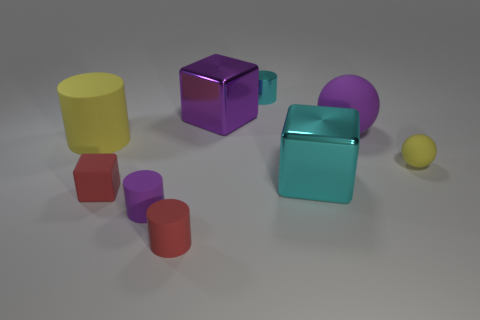How many other objects are there of the same material as the small purple cylinder?
Your answer should be very brief. 5. Do the big object that is on the right side of the large cyan block and the purple thing that is in front of the small ball have the same material?
Provide a succinct answer. Yes. The tiny thing that is the same material as the cyan cube is what shape?
Offer a terse response. Cylinder. Are there any other things that have the same color as the small metal cylinder?
Keep it short and to the point. Yes. How many purple shiny balls are there?
Give a very brief answer. 0. What shape is the metallic object that is both on the right side of the purple shiny object and behind the big purple sphere?
Your answer should be compact. Cylinder. There is a tiny metallic thing behind the large matte object on the right side of the large cube left of the small shiny cylinder; what shape is it?
Your answer should be very brief. Cylinder. What material is the tiny thing that is both in front of the big yellow rubber object and behind the red rubber cube?
Make the answer very short. Rubber. What number of gray metallic things are the same size as the purple rubber ball?
Your answer should be very brief. 0. What number of rubber objects are large yellow cylinders or small cyan cylinders?
Offer a very short reply. 1. 